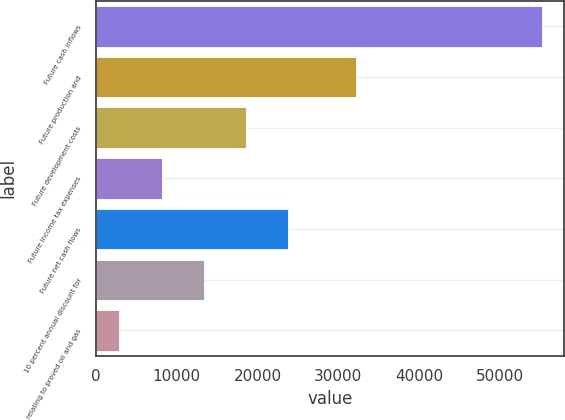Convert chart to OTSL. <chart><loc_0><loc_0><loc_500><loc_500><bar_chart><fcel>Future cash inflows<fcel>Future production and<fcel>Future development costs<fcel>Future income tax expenses<fcel>Future net cash flows<fcel>10 percent annual discount for<fcel>relating to proved oil and gas<nl><fcel>55171<fcel>32131<fcel>18581.3<fcel>8127.1<fcel>23808.4<fcel>13354.2<fcel>2900<nl></chart> 